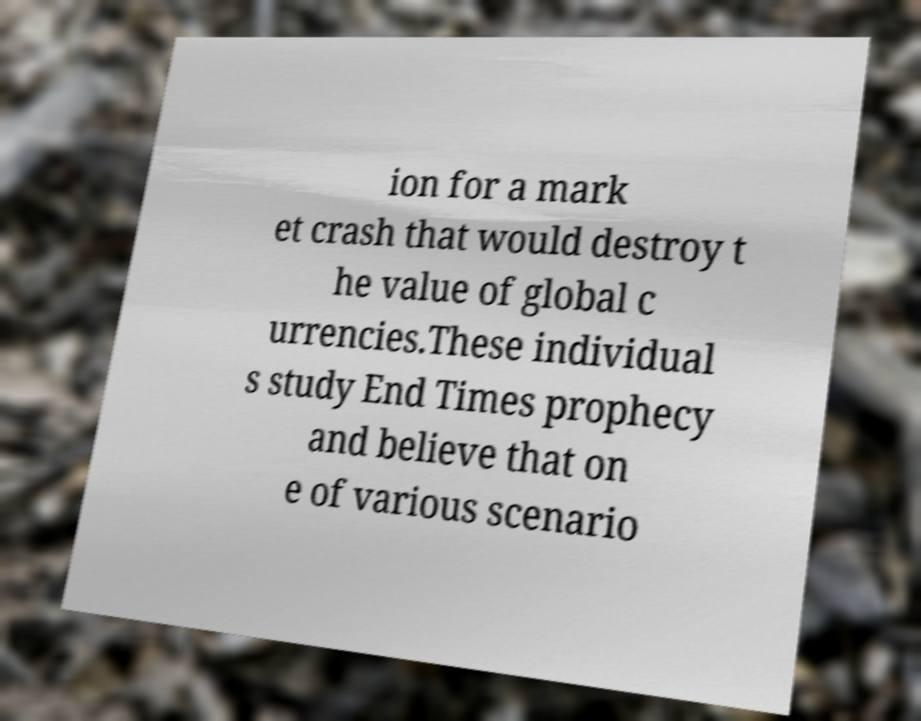Please identify and transcribe the text found in this image. ion for a mark et crash that would destroy t he value of global c urrencies.These individual s study End Times prophecy and believe that on e of various scenario 